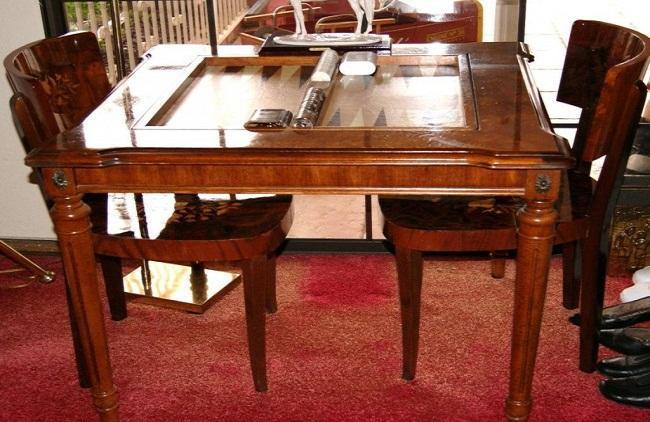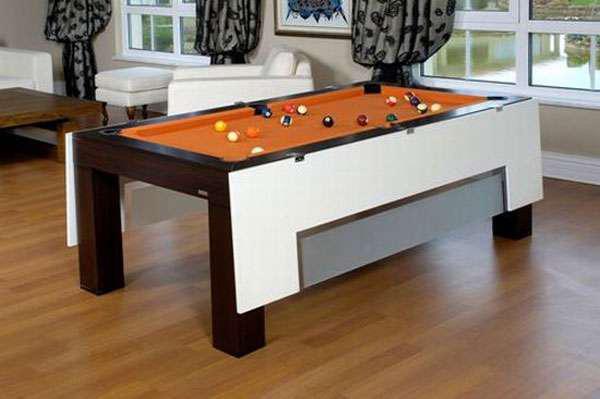The first image is the image on the left, the second image is the image on the right. For the images displayed, is the sentence "An image shows a rectangular table with wood border, charcoal center, and no chairs." factually correct? Answer yes or no. No. 